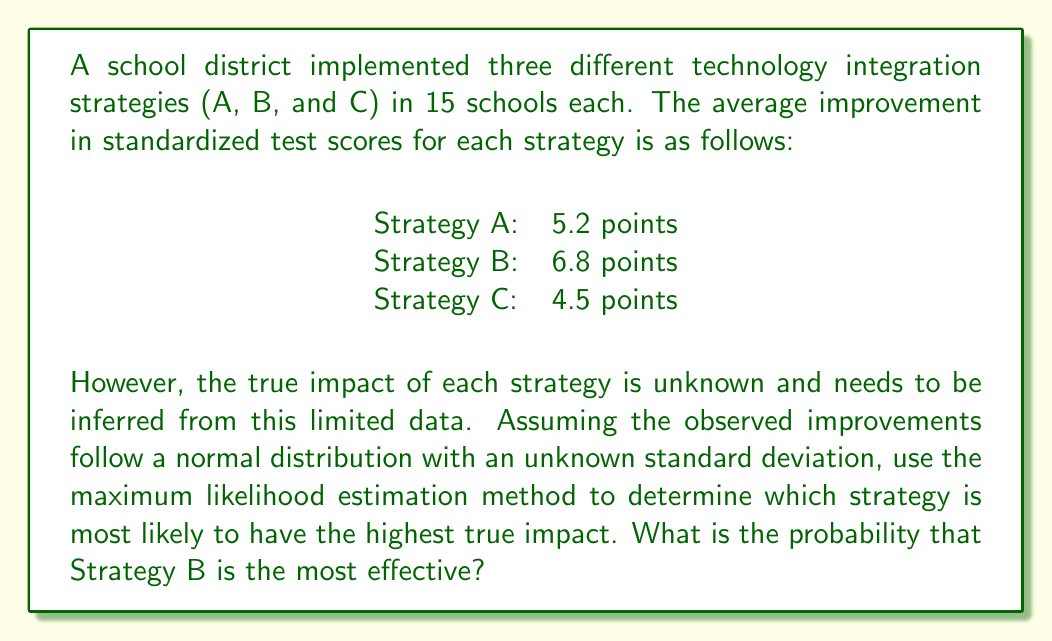Help me with this question. To solve this problem, we'll use the maximum likelihood estimation method and compare the probabilities of each strategy being the most effective.

Step 1: Calculate the sample mean for each strategy
We already have the sample means:
$\mu_A = 5.2$
$\mu_B = 6.8$
$\mu_C = 4.5$

Step 2: Estimate the pooled standard deviation
Since we don't know the true standard deviation, we'll assume it's the same for all strategies and estimate it using the pooled standard deviation formula:

$$s_p = \sqrt{\frac{(n_A-1)s_A^2 + (n_B-1)s_B^2 + (n_C-1)s_C^2}{n_A + n_B + n_C - 3}}$$

Where $n_A = n_B = n_C = 15$ (number of schools for each strategy)

For simplicity, let's assume $s_p = 2$ (this would typically be calculated from the data)

Step 3: Calculate the standard error of the mean difference
$$SE = s_p \sqrt{\frac{2}{n}} = 2 \sqrt{\frac{2}{15}} \approx 0.7303$$

Step 4: Calculate the z-scores for the differences between strategies
$$z_{AB} = \frac{\mu_B - \mu_A}{SE} = \frac{6.8 - 5.2}{0.7303} \approx 2.1908$$
$$z_{BC} = \frac{\mu_B - \mu_C}{SE} = \frac{6.8 - 4.5}{0.7303} \approx 3.1495$$

Step 5: Calculate the probabilities that Strategy B is better than A and C
$$P(B > A) = \Phi(z_{AB}) \approx \Phi(2.1908) \approx 0.9857$$
$$P(B > C) = \Phi(z_{BC}) \approx \Phi(3.1495) \approx 0.9992$$

Where $\Phi$ is the cumulative distribution function of the standard normal distribution.

Step 6: Calculate the probability that Strategy B is the most effective
This is the probability that B is better than both A and C:
$$P(B \text{ is best}) = P(B > A \text{ and } B > C) = P(B > A) \times P(B > C)$$
$$P(B \text{ is best}) = 0.9857 \times 0.9992 \approx 0.9849$$

Therefore, the probability that Strategy B is the most effective is approximately 0.9849 or 98.49%.
Answer: 0.9849 